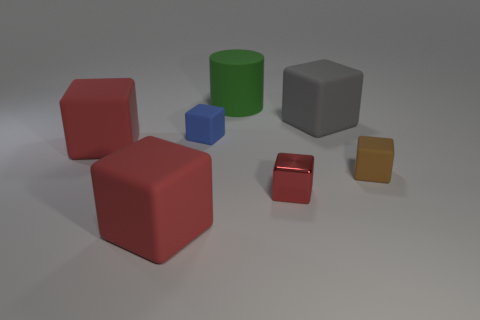Subtract all blue balls. How many red cubes are left? 3 Subtract all gray cubes. How many cubes are left? 5 Subtract all small red metal cubes. How many cubes are left? 5 Subtract all purple cubes. Subtract all blue balls. How many cubes are left? 6 Add 2 small matte objects. How many objects exist? 9 Subtract all cylinders. How many objects are left? 6 Add 4 green matte cylinders. How many green matte cylinders exist? 5 Subtract 0 yellow cubes. How many objects are left? 7 Subtract all small cyan matte balls. Subtract all big gray things. How many objects are left? 6 Add 1 rubber cylinders. How many rubber cylinders are left? 2 